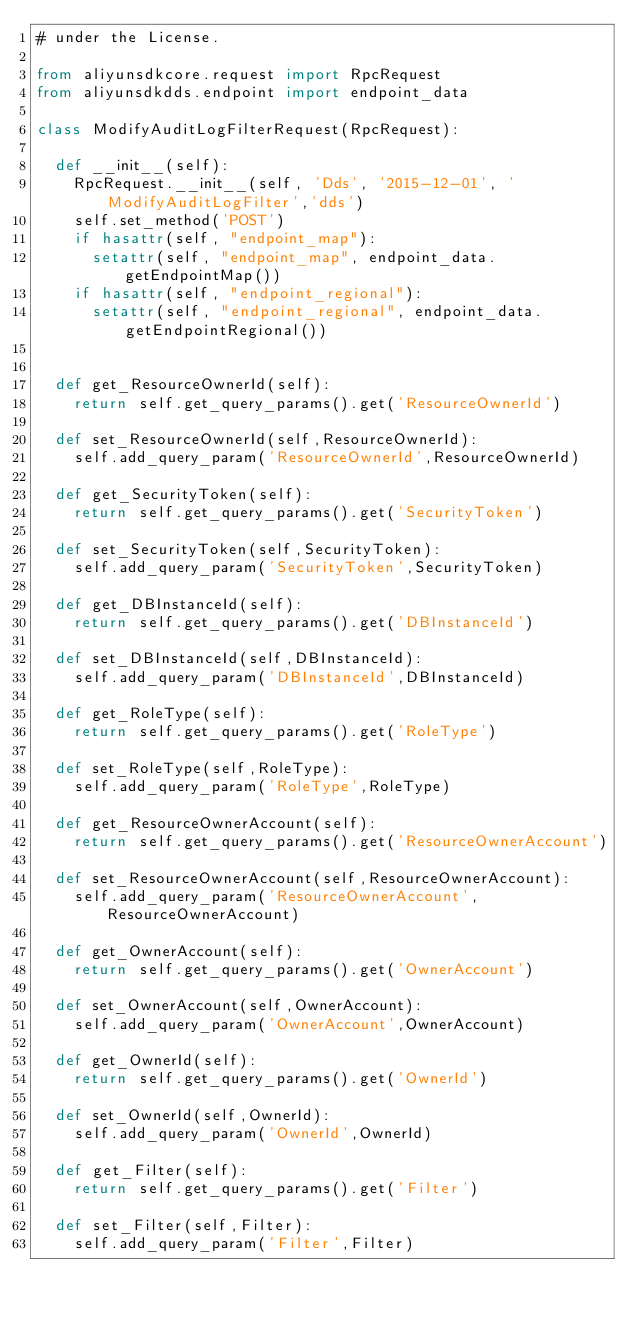Convert code to text. <code><loc_0><loc_0><loc_500><loc_500><_Python_># under the License.

from aliyunsdkcore.request import RpcRequest
from aliyunsdkdds.endpoint import endpoint_data

class ModifyAuditLogFilterRequest(RpcRequest):

	def __init__(self):
		RpcRequest.__init__(self, 'Dds', '2015-12-01', 'ModifyAuditLogFilter','dds')
		self.set_method('POST')
		if hasattr(self, "endpoint_map"):
			setattr(self, "endpoint_map", endpoint_data.getEndpointMap())
		if hasattr(self, "endpoint_regional"):
			setattr(self, "endpoint_regional", endpoint_data.getEndpointRegional())


	def get_ResourceOwnerId(self):
		return self.get_query_params().get('ResourceOwnerId')

	def set_ResourceOwnerId(self,ResourceOwnerId):
		self.add_query_param('ResourceOwnerId',ResourceOwnerId)

	def get_SecurityToken(self):
		return self.get_query_params().get('SecurityToken')

	def set_SecurityToken(self,SecurityToken):
		self.add_query_param('SecurityToken',SecurityToken)

	def get_DBInstanceId(self):
		return self.get_query_params().get('DBInstanceId')

	def set_DBInstanceId(self,DBInstanceId):
		self.add_query_param('DBInstanceId',DBInstanceId)

	def get_RoleType(self):
		return self.get_query_params().get('RoleType')

	def set_RoleType(self,RoleType):
		self.add_query_param('RoleType',RoleType)

	def get_ResourceOwnerAccount(self):
		return self.get_query_params().get('ResourceOwnerAccount')

	def set_ResourceOwnerAccount(self,ResourceOwnerAccount):
		self.add_query_param('ResourceOwnerAccount',ResourceOwnerAccount)

	def get_OwnerAccount(self):
		return self.get_query_params().get('OwnerAccount')

	def set_OwnerAccount(self,OwnerAccount):
		self.add_query_param('OwnerAccount',OwnerAccount)

	def get_OwnerId(self):
		return self.get_query_params().get('OwnerId')

	def set_OwnerId(self,OwnerId):
		self.add_query_param('OwnerId',OwnerId)

	def get_Filter(self):
		return self.get_query_params().get('Filter')

	def set_Filter(self,Filter):
		self.add_query_param('Filter',Filter)</code> 